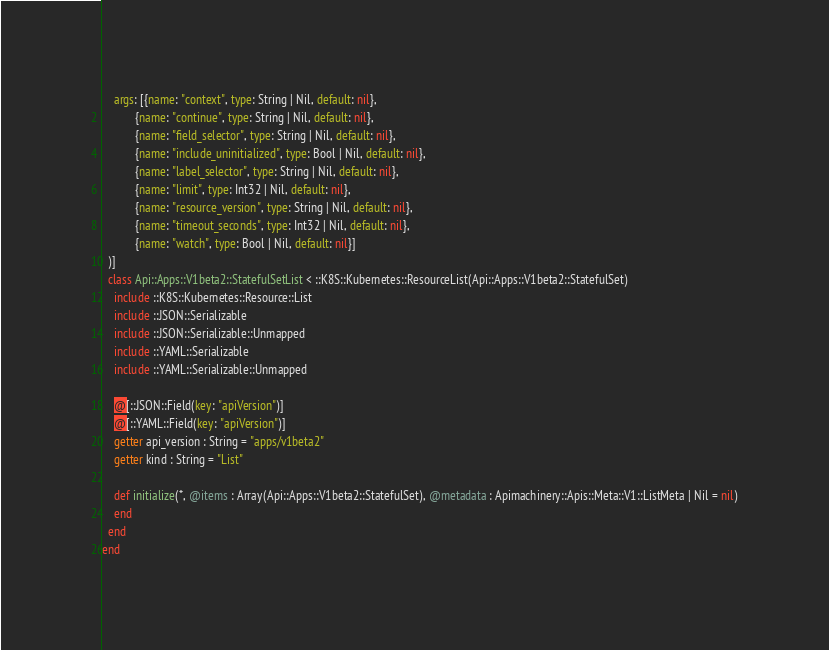<code> <loc_0><loc_0><loc_500><loc_500><_Crystal_>    args: [{name: "context", type: String | Nil, default: nil},
           {name: "continue", type: String | Nil, default: nil},
           {name: "field_selector", type: String | Nil, default: nil},
           {name: "include_uninitialized", type: Bool | Nil, default: nil},
           {name: "label_selector", type: String | Nil, default: nil},
           {name: "limit", type: Int32 | Nil, default: nil},
           {name: "resource_version", type: String | Nil, default: nil},
           {name: "timeout_seconds", type: Int32 | Nil, default: nil},
           {name: "watch", type: Bool | Nil, default: nil}]
  )]
  class Api::Apps::V1beta2::StatefulSetList < ::K8S::Kubernetes::ResourceList(Api::Apps::V1beta2::StatefulSet)
    include ::K8S::Kubernetes::Resource::List
    include ::JSON::Serializable
    include ::JSON::Serializable::Unmapped
    include ::YAML::Serializable
    include ::YAML::Serializable::Unmapped

    @[::JSON::Field(key: "apiVersion")]
    @[::YAML::Field(key: "apiVersion")]
    getter api_version : String = "apps/v1beta2"
    getter kind : String = "List"

    def initialize(*, @items : Array(Api::Apps::V1beta2::StatefulSet), @metadata : Apimachinery::Apis::Meta::V1::ListMeta | Nil = nil)
    end
  end
end
</code> 